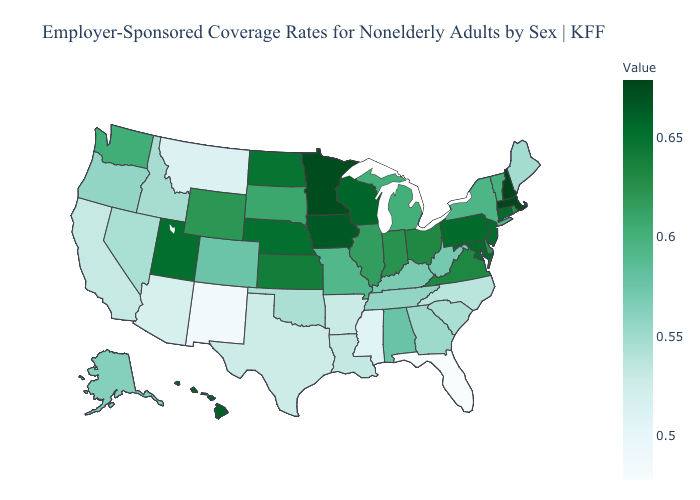Among the states that border Missouri , does Arkansas have the highest value?
Quick response, please. No. Among the states that border Florida , does Alabama have the lowest value?
Concise answer only. No. Which states have the highest value in the USA?
Keep it brief. New Hampshire. Does Maryland have the highest value in the South?
Concise answer only. Yes. Which states have the lowest value in the USA?
Short answer required. Florida. Which states hav the highest value in the MidWest?
Keep it brief. Minnesota. Which states have the highest value in the USA?
Short answer required. New Hampshire. 